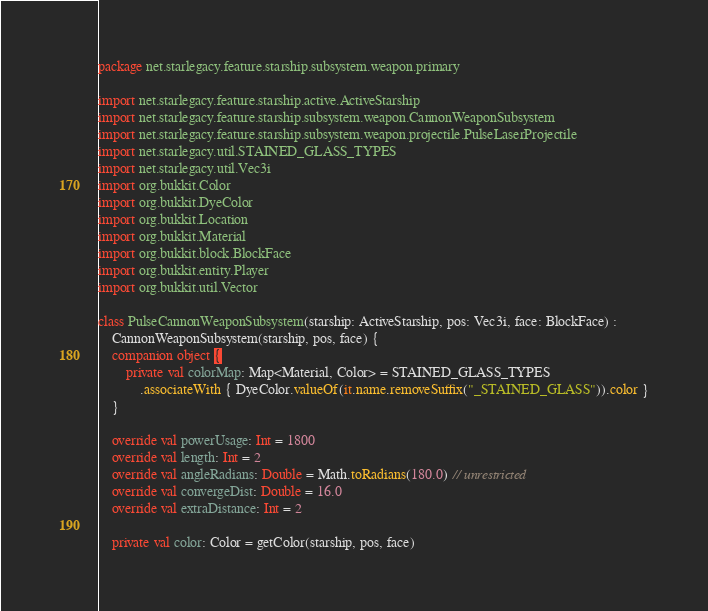<code> <loc_0><loc_0><loc_500><loc_500><_Kotlin_>package net.starlegacy.feature.starship.subsystem.weapon.primary

import net.starlegacy.feature.starship.active.ActiveStarship
import net.starlegacy.feature.starship.subsystem.weapon.CannonWeaponSubsystem
import net.starlegacy.feature.starship.subsystem.weapon.projectile.PulseLaserProjectile
import net.starlegacy.util.STAINED_GLASS_TYPES
import net.starlegacy.util.Vec3i
import org.bukkit.Color
import org.bukkit.DyeColor
import org.bukkit.Location
import org.bukkit.Material
import org.bukkit.block.BlockFace
import org.bukkit.entity.Player
import org.bukkit.util.Vector

class PulseCannonWeaponSubsystem(starship: ActiveStarship, pos: Vec3i, face: BlockFace) :
    CannonWeaponSubsystem(starship, pos, face) {
    companion object {
        private val colorMap: Map<Material, Color> = STAINED_GLASS_TYPES
            .associateWith { DyeColor.valueOf(it.name.removeSuffix("_STAINED_GLASS")).color }
    }

    override val powerUsage: Int = 1800
    override val length: Int = 2
    override val angleRadians: Double = Math.toRadians(180.0) // unrestricted
    override val convergeDist: Double = 16.0
    override val extraDistance: Int = 2

    private val color: Color = getColor(starship, pos, face)
</code> 